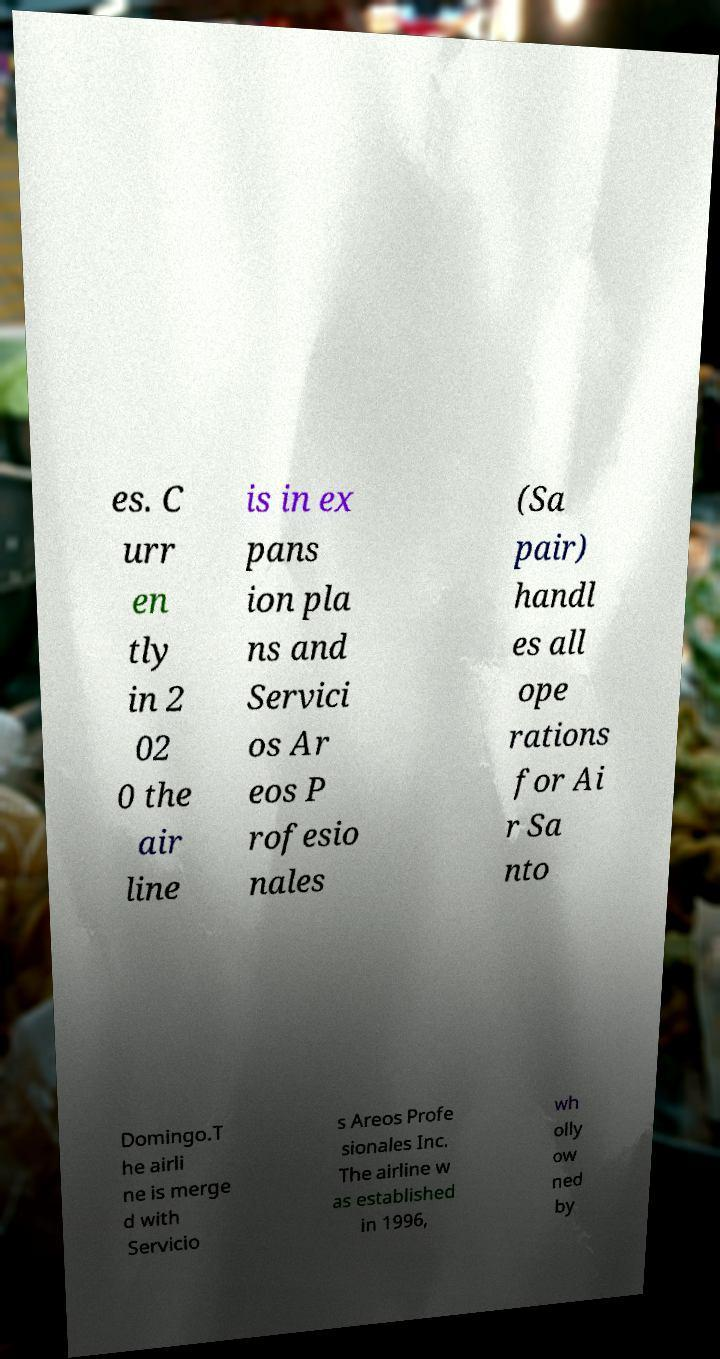I need the written content from this picture converted into text. Can you do that? es. C urr en tly in 2 02 0 the air line is in ex pans ion pla ns and Servici os Ar eos P rofesio nales (Sa pair) handl es all ope rations for Ai r Sa nto Domingo.T he airli ne is merge d with Servicio s Areos Profe sionales Inc. The airline w as established in 1996, wh olly ow ned by 